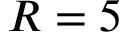<formula> <loc_0><loc_0><loc_500><loc_500>R = 5</formula> 